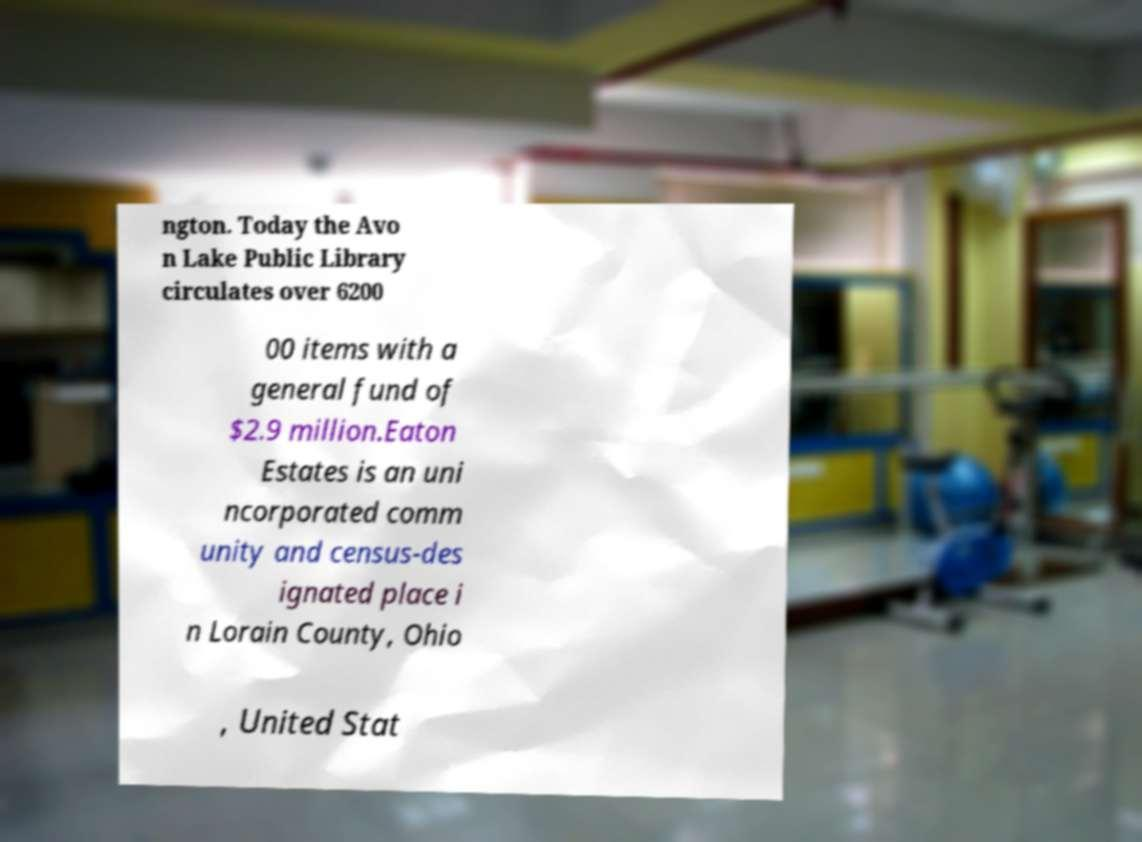I need the written content from this picture converted into text. Can you do that? ngton. Today the Avo n Lake Public Library circulates over 6200 00 items with a general fund of $2.9 million.Eaton Estates is an uni ncorporated comm unity and census-des ignated place i n Lorain County, Ohio , United Stat 